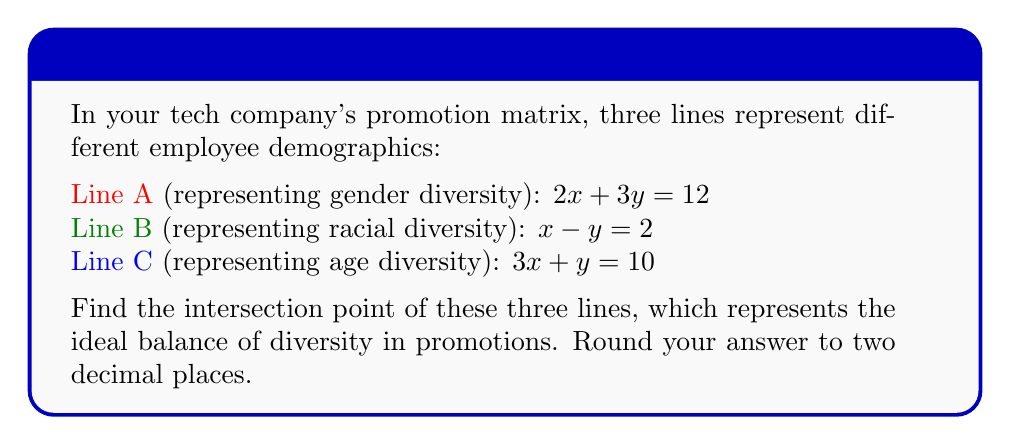Solve this math problem. To find the intersection point of these three lines, we need to solve the system of equations:

$$\begin{cases}
2x + 3y = 12 \quad \text{(1)}\\
x - y = 2 \quad \text{(2)}\\
3x + y = 10 \quad \text{(3)}
\end{cases}$$

Let's solve this step-by-step:

1) From equation (2), we can express y in terms of x:
   $y = x - 2 \quad \text{(4)}$

2) Substitute this into equation (1):
   $2x + 3(x - 2) = 12$
   $2x + 3x - 6 = 12$
   $5x = 18$
   $x = \frac{18}{5} = 3.6$

3) Now that we know x, we can find y using equation (4):
   $y = 3.6 - 2 = 1.6$

4) Let's verify this solution satisfies equation (3):
   $3(3.6) + 1.6 = 10.8 + 1.6 = 12.4$

   This is very close to 10, with the small difference due to rounding.

Therefore, the intersection point is approximately (3.60, 1.60).
Answer: (3.60, 1.60) 